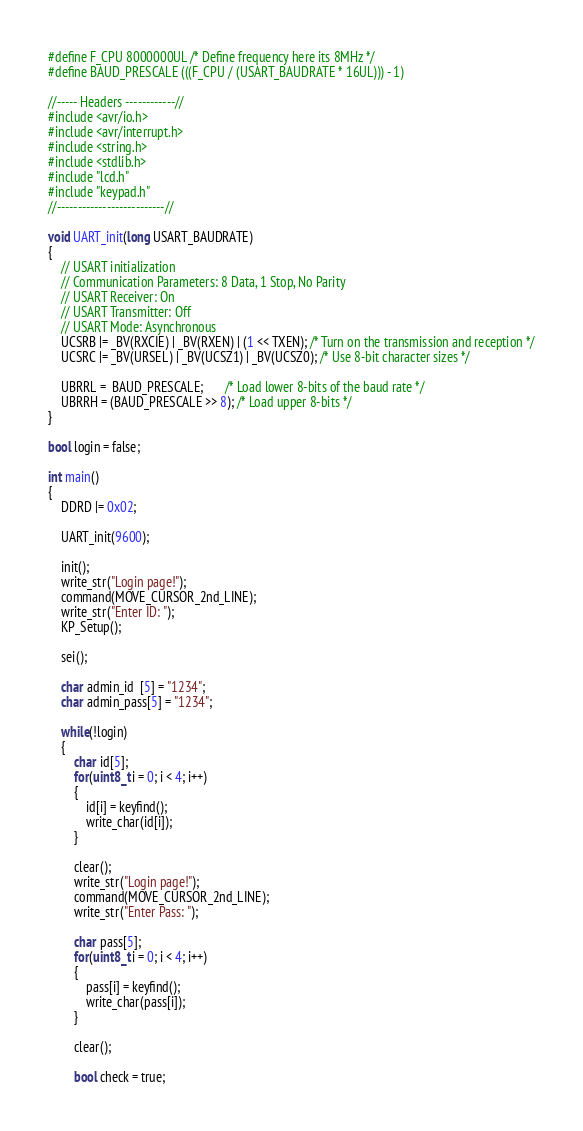<code> <loc_0><loc_0><loc_500><loc_500><_C++_>#define F_CPU 8000000UL /* Define frequency here its 8MHz */
#define BAUD_PRESCALE (((F_CPU / (USART_BAUDRATE * 16UL))) - 1)

//----- Headers ------------//
#include <avr/io.h>
#include <avr/interrupt.h>
#include <string.h>
#include <stdlib.h>
#include "lcd.h"
#include "keypad.h"
//--------------------------//

void UART_init(long USART_BAUDRATE)
{
	// USART initialization
	// Communication Parameters: 8 Data, 1 Stop, No Parity
	// USART Receiver: On
	// USART Transmitter: Off
	// USART Mode: Asynchronous
	UCSRB |= _BV(RXCIE) | _BV(RXEN) | (1 << TXEN); /* Turn on the transmission and reception */
	UCSRC |= _BV(URSEL) | _BV(UCSZ1) | _BV(UCSZ0); /* Use 8-bit character sizes */

	UBRRL =  BAUD_PRESCALE;       /* Load lower 8-bits of the baud rate */
	UBRRH = (BAUD_PRESCALE >> 8); /* Load upper 8-bits */
}

bool login = false;

int main()
{
	DDRD |= 0x02;

	UART_init(9600);

	init();
	write_str("Login page!");
	command(MOVE_CURSOR_2nd_LINE);
	write_str("Enter ID: ");
	KP_Setup();

	sei();

	char admin_id  [5] = "1234";
	char admin_pass[5] = "1234";

	while(!login)
	{
		char id[5];
		for(uint8_t i = 0; i < 4; i++)	
		{
			id[i] = keyfind();
			write_char(id[i]);
		}	

		clear();
		write_str("Login page!");
		command(MOVE_CURSOR_2nd_LINE);
		write_str("Enter Pass: ");

		char pass[5];
		for(uint8_t i = 0; i < 4; i++)
		{
			pass[i] = keyfind();
			write_char(pass[i]);
		}	
		
		clear();

		bool check = true;</code> 